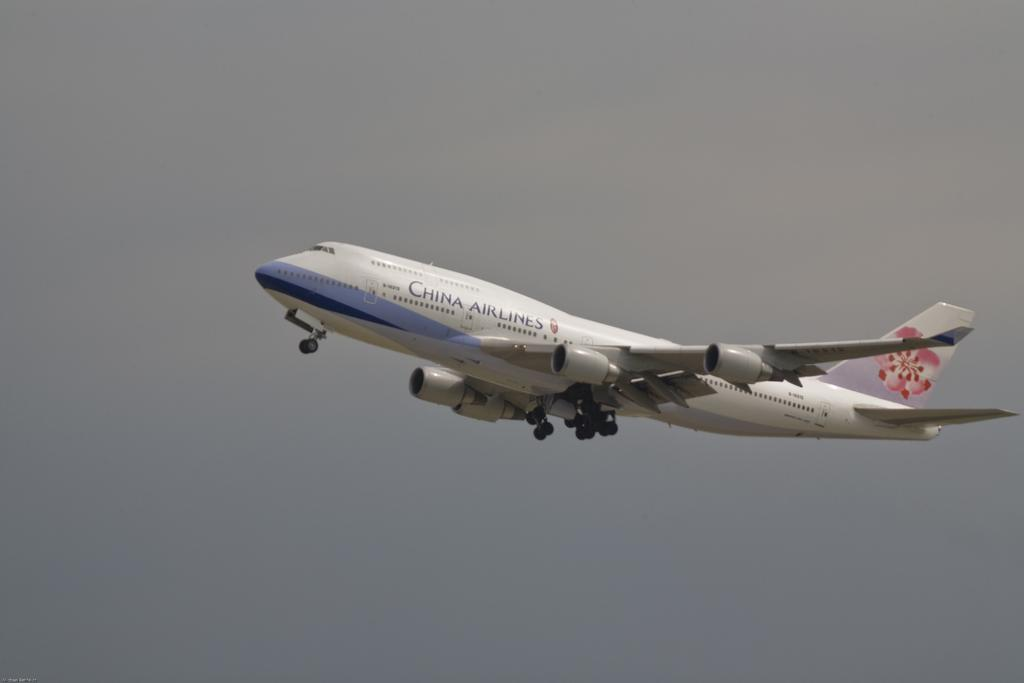What is the main subject of the image? The main subject of the image is an airplane. What is the airplane doing in the image? The airplane is flying in the air. What can be seen in the background of the image? The sky is visible in the background of the image. Reasoning: Let's think step by step to produce the conversation. We start by mentioning the main subject of the image, which is the airplane. Then, we describe the action of the airplane, which is flying in the air. Finally, we mention the background of the image, which is the sky. Absurd Question/Answer: What type of songs can be heard coming from the airplane in the image? There is no indication in the image that any songs are being played or heard from the airplane. 